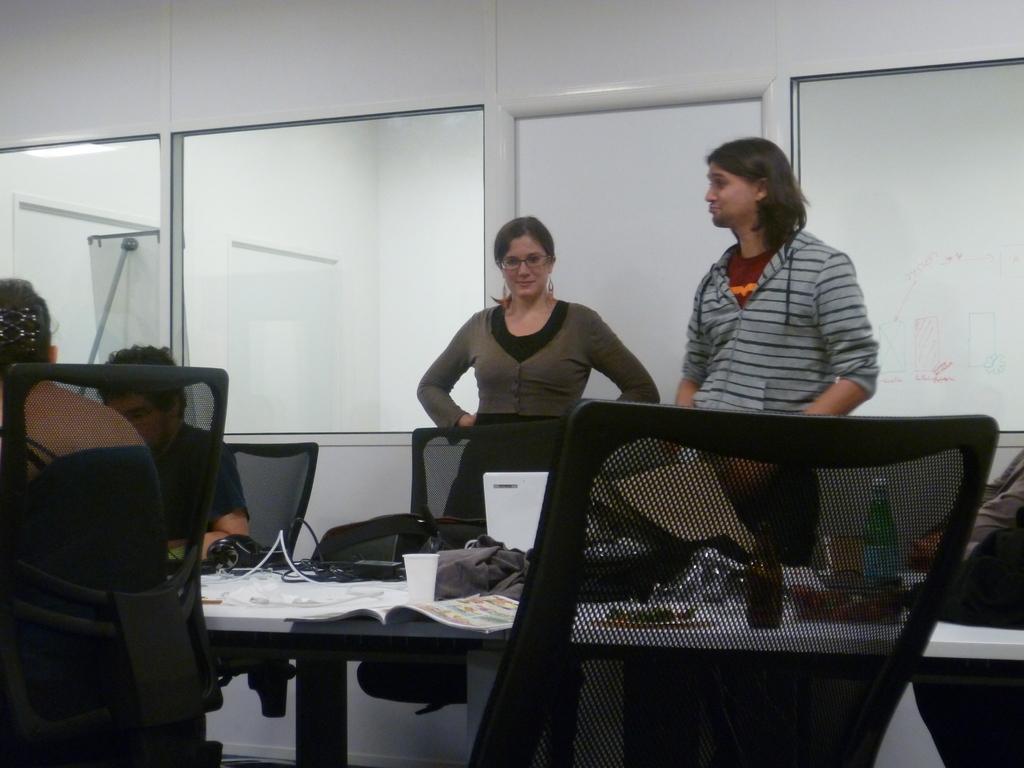Could you give a brief overview of what you see in this image? In this image I can see number of people where two of them are standing and rest all are sitting. Here on this table I can see few bottles and few books. 